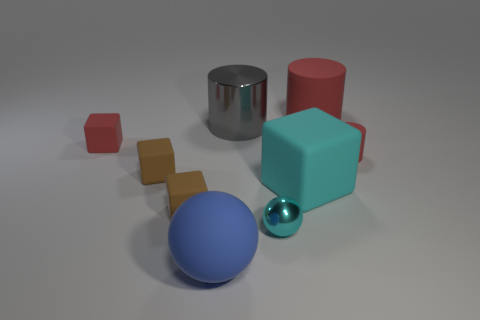There is a large block that is the same color as the metallic ball; what material is it? Based on the image, we cannot determine the material of the block solely by its color. However, if we were to speculate, given the context of the image which seems to exhibit simple geometrical shapes possibly for a visual study, the large turquoise block may be made of a matte painted wood or plastic to imitate the appearance of the smaller, shiny metallic ball. 